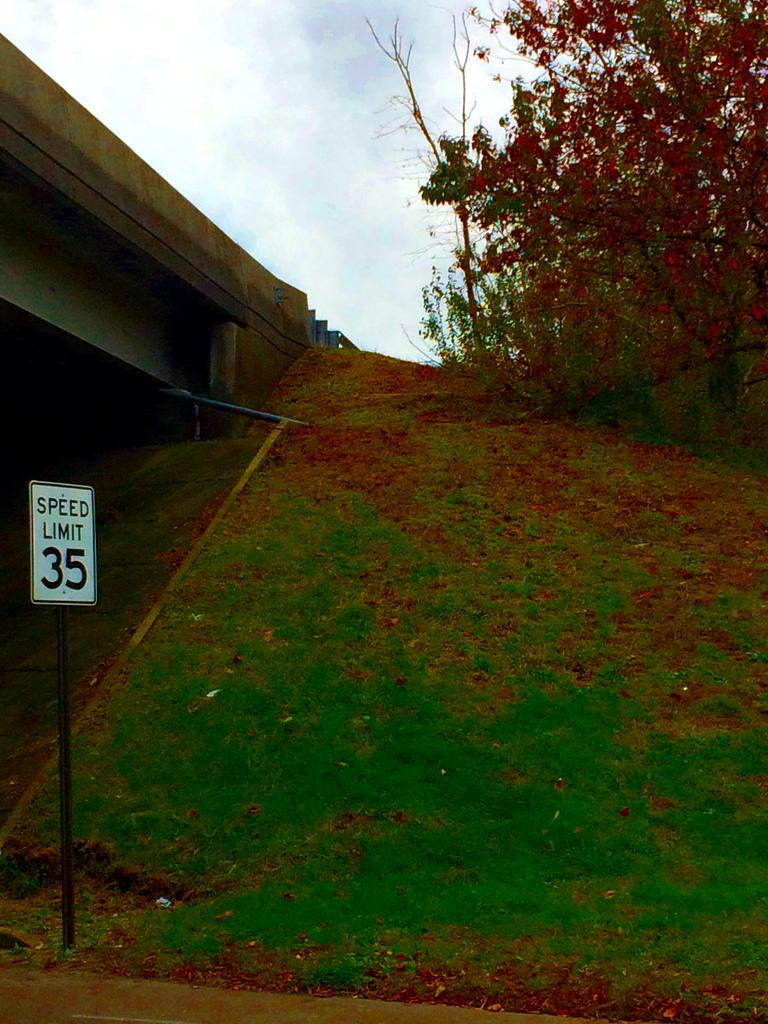What can be seen in the foreground of the picture? There are dry leaves, grass, and a pole in the foreground of the picture. What is located on the left side of the picture? There is a bridge on the left side of the picture. What is present on the right side of the picture? There are trees on the right side of the picture. How would you describe the sky in the picture? The sky is cloudy in the picture. Can you tell me what type of agreement was reached by the band on the side of the bridge? There is no band or agreement mentioned in the image; it features dry leaves, grass, a pole, a bridge, trees, and a cloudy sky. 